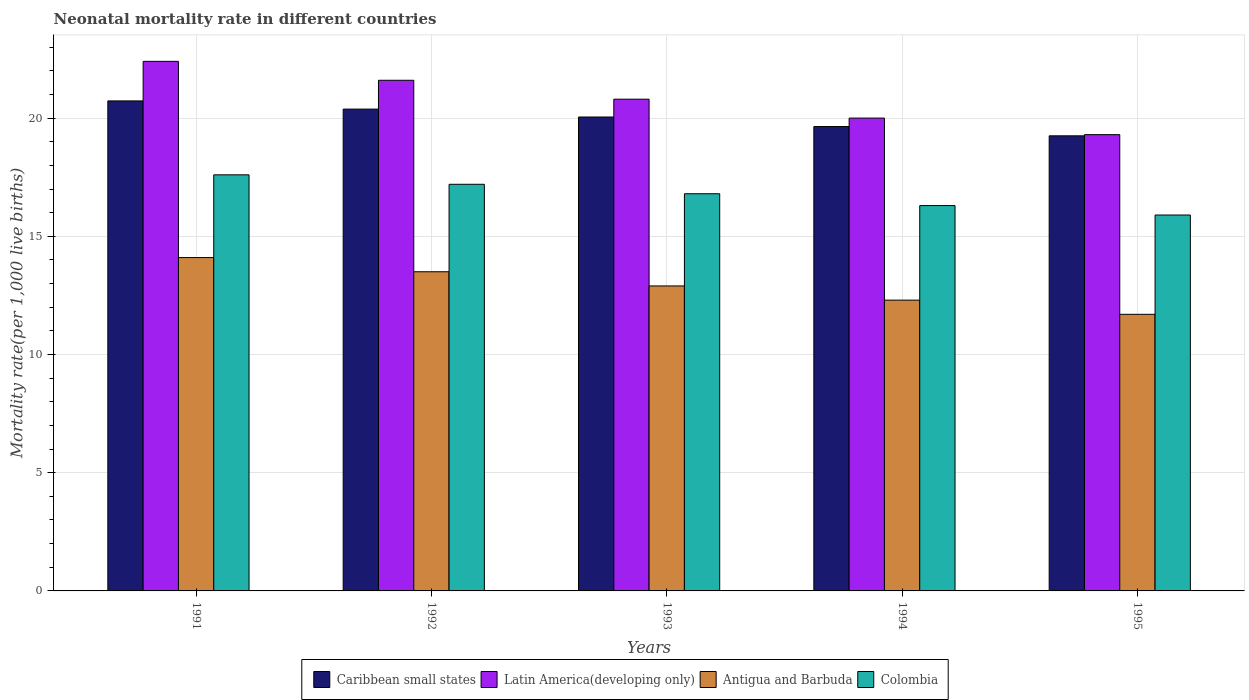How many different coloured bars are there?
Your response must be concise. 4. How many groups of bars are there?
Offer a very short reply. 5. How many bars are there on the 5th tick from the right?
Your answer should be very brief. 4. What is the neonatal mortality rate in Caribbean small states in 1994?
Offer a very short reply. 19.64. Across all years, what is the maximum neonatal mortality rate in Antigua and Barbuda?
Offer a very short reply. 14.1. Across all years, what is the minimum neonatal mortality rate in Antigua and Barbuda?
Offer a terse response. 11.7. In which year was the neonatal mortality rate in Caribbean small states maximum?
Your answer should be very brief. 1991. In which year was the neonatal mortality rate in Latin America(developing only) minimum?
Your answer should be very brief. 1995. What is the total neonatal mortality rate in Caribbean small states in the graph?
Provide a short and direct response. 100.05. What is the difference between the neonatal mortality rate in Antigua and Barbuda in 1993 and that in 1995?
Offer a very short reply. 1.2. What is the difference between the neonatal mortality rate in Caribbean small states in 1994 and the neonatal mortality rate in Latin America(developing only) in 1995?
Offer a terse response. 0.34. What is the average neonatal mortality rate in Caribbean small states per year?
Make the answer very short. 20.01. In the year 1995, what is the difference between the neonatal mortality rate in Latin America(developing only) and neonatal mortality rate in Antigua and Barbuda?
Make the answer very short. 7.6. What is the ratio of the neonatal mortality rate in Antigua and Barbuda in 1991 to that in 1992?
Ensure brevity in your answer.  1.04. What is the difference between the highest and the second highest neonatal mortality rate in Antigua and Barbuda?
Your answer should be compact. 0.6. What is the difference between the highest and the lowest neonatal mortality rate in Antigua and Barbuda?
Your answer should be compact. 2.4. Is the sum of the neonatal mortality rate in Caribbean small states in 1994 and 1995 greater than the maximum neonatal mortality rate in Latin America(developing only) across all years?
Provide a succinct answer. Yes. What does the 3rd bar from the left in 1994 represents?
Ensure brevity in your answer.  Antigua and Barbuda. What does the 3rd bar from the right in 1991 represents?
Ensure brevity in your answer.  Latin America(developing only). Is it the case that in every year, the sum of the neonatal mortality rate in Antigua and Barbuda and neonatal mortality rate in Latin America(developing only) is greater than the neonatal mortality rate in Caribbean small states?
Your answer should be compact. Yes. Are the values on the major ticks of Y-axis written in scientific E-notation?
Offer a very short reply. No. Does the graph contain any zero values?
Offer a very short reply. No. How are the legend labels stacked?
Your answer should be compact. Horizontal. What is the title of the graph?
Your answer should be very brief. Neonatal mortality rate in different countries. Does "Mexico" appear as one of the legend labels in the graph?
Give a very brief answer. No. What is the label or title of the Y-axis?
Your response must be concise. Mortality rate(per 1,0 live births). What is the Mortality rate(per 1,000 live births) of Caribbean small states in 1991?
Your response must be concise. 20.73. What is the Mortality rate(per 1,000 live births) of Latin America(developing only) in 1991?
Give a very brief answer. 22.4. What is the Mortality rate(per 1,000 live births) of Antigua and Barbuda in 1991?
Make the answer very short. 14.1. What is the Mortality rate(per 1,000 live births) of Colombia in 1991?
Provide a short and direct response. 17.6. What is the Mortality rate(per 1,000 live births) in Caribbean small states in 1992?
Provide a succinct answer. 20.38. What is the Mortality rate(per 1,000 live births) in Latin America(developing only) in 1992?
Ensure brevity in your answer.  21.6. What is the Mortality rate(per 1,000 live births) of Antigua and Barbuda in 1992?
Keep it short and to the point. 13.5. What is the Mortality rate(per 1,000 live births) in Caribbean small states in 1993?
Ensure brevity in your answer.  20.05. What is the Mortality rate(per 1,000 live births) of Latin America(developing only) in 1993?
Keep it short and to the point. 20.8. What is the Mortality rate(per 1,000 live births) in Antigua and Barbuda in 1993?
Offer a very short reply. 12.9. What is the Mortality rate(per 1,000 live births) of Colombia in 1993?
Make the answer very short. 16.8. What is the Mortality rate(per 1,000 live births) in Caribbean small states in 1994?
Your answer should be compact. 19.64. What is the Mortality rate(per 1,000 live births) of Antigua and Barbuda in 1994?
Your answer should be very brief. 12.3. What is the Mortality rate(per 1,000 live births) in Caribbean small states in 1995?
Offer a very short reply. 19.25. What is the Mortality rate(per 1,000 live births) of Latin America(developing only) in 1995?
Ensure brevity in your answer.  19.3. What is the Mortality rate(per 1,000 live births) in Colombia in 1995?
Offer a terse response. 15.9. Across all years, what is the maximum Mortality rate(per 1,000 live births) in Caribbean small states?
Ensure brevity in your answer.  20.73. Across all years, what is the maximum Mortality rate(per 1,000 live births) of Latin America(developing only)?
Your answer should be very brief. 22.4. Across all years, what is the minimum Mortality rate(per 1,000 live births) of Caribbean small states?
Your answer should be compact. 19.25. Across all years, what is the minimum Mortality rate(per 1,000 live births) in Latin America(developing only)?
Offer a very short reply. 19.3. Across all years, what is the minimum Mortality rate(per 1,000 live births) of Antigua and Barbuda?
Give a very brief answer. 11.7. What is the total Mortality rate(per 1,000 live births) of Caribbean small states in the graph?
Provide a short and direct response. 100.05. What is the total Mortality rate(per 1,000 live births) of Latin America(developing only) in the graph?
Give a very brief answer. 104.1. What is the total Mortality rate(per 1,000 live births) in Antigua and Barbuda in the graph?
Offer a terse response. 64.5. What is the total Mortality rate(per 1,000 live births) of Colombia in the graph?
Your response must be concise. 83.8. What is the difference between the Mortality rate(per 1,000 live births) in Caribbean small states in 1991 and that in 1992?
Your answer should be compact. 0.35. What is the difference between the Mortality rate(per 1,000 live births) in Antigua and Barbuda in 1991 and that in 1992?
Your response must be concise. 0.6. What is the difference between the Mortality rate(per 1,000 live births) in Caribbean small states in 1991 and that in 1993?
Ensure brevity in your answer.  0.68. What is the difference between the Mortality rate(per 1,000 live births) in Antigua and Barbuda in 1991 and that in 1993?
Provide a short and direct response. 1.2. What is the difference between the Mortality rate(per 1,000 live births) of Colombia in 1991 and that in 1993?
Offer a very short reply. 0.8. What is the difference between the Mortality rate(per 1,000 live births) in Caribbean small states in 1991 and that in 1994?
Your answer should be compact. 1.08. What is the difference between the Mortality rate(per 1,000 live births) in Latin America(developing only) in 1991 and that in 1994?
Ensure brevity in your answer.  2.4. What is the difference between the Mortality rate(per 1,000 live births) in Antigua and Barbuda in 1991 and that in 1994?
Your answer should be compact. 1.8. What is the difference between the Mortality rate(per 1,000 live births) in Colombia in 1991 and that in 1994?
Offer a very short reply. 1.3. What is the difference between the Mortality rate(per 1,000 live births) in Caribbean small states in 1991 and that in 1995?
Give a very brief answer. 1.48. What is the difference between the Mortality rate(per 1,000 live births) of Colombia in 1991 and that in 1995?
Your answer should be very brief. 1.7. What is the difference between the Mortality rate(per 1,000 live births) in Caribbean small states in 1992 and that in 1993?
Your answer should be compact. 0.33. What is the difference between the Mortality rate(per 1,000 live births) of Latin America(developing only) in 1992 and that in 1993?
Ensure brevity in your answer.  0.8. What is the difference between the Mortality rate(per 1,000 live births) in Caribbean small states in 1992 and that in 1994?
Provide a succinct answer. 0.74. What is the difference between the Mortality rate(per 1,000 live births) of Antigua and Barbuda in 1992 and that in 1994?
Your answer should be very brief. 1.2. What is the difference between the Mortality rate(per 1,000 live births) in Colombia in 1992 and that in 1994?
Make the answer very short. 0.9. What is the difference between the Mortality rate(per 1,000 live births) in Caribbean small states in 1992 and that in 1995?
Your answer should be compact. 1.13. What is the difference between the Mortality rate(per 1,000 live births) of Latin America(developing only) in 1992 and that in 1995?
Make the answer very short. 2.3. What is the difference between the Mortality rate(per 1,000 live births) in Caribbean small states in 1993 and that in 1994?
Keep it short and to the point. 0.4. What is the difference between the Mortality rate(per 1,000 live births) of Colombia in 1993 and that in 1994?
Make the answer very short. 0.5. What is the difference between the Mortality rate(per 1,000 live births) in Caribbean small states in 1993 and that in 1995?
Offer a very short reply. 0.8. What is the difference between the Mortality rate(per 1,000 live births) in Caribbean small states in 1994 and that in 1995?
Your answer should be compact. 0.39. What is the difference between the Mortality rate(per 1,000 live births) in Antigua and Barbuda in 1994 and that in 1995?
Give a very brief answer. 0.6. What is the difference between the Mortality rate(per 1,000 live births) of Caribbean small states in 1991 and the Mortality rate(per 1,000 live births) of Latin America(developing only) in 1992?
Provide a succinct answer. -0.87. What is the difference between the Mortality rate(per 1,000 live births) of Caribbean small states in 1991 and the Mortality rate(per 1,000 live births) of Antigua and Barbuda in 1992?
Keep it short and to the point. 7.23. What is the difference between the Mortality rate(per 1,000 live births) of Caribbean small states in 1991 and the Mortality rate(per 1,000 live births) of Colombia in 1992?
Offer a terse response. 3.53. What is the difference between the Mortality rate(per 1,000 live births) in Latin America(developing only) in 1991 and the Mortality rate(per 1,000 live births) in Colombia in 1992?
Provide a succinct answer. 5.2. What is the difference between the Mortality rate(per 1,000 live births) in Caribbean small states in 1991 and the Mortality rate(per 1,000 live births) in Latin America(developing only) in 1993?
Give a very brief answer. -0.07. What is the difference between the Mortality rate(per 1,000 live births) of Caribbean small states in 1991 and the Mortality rate(per 1,000 live births) of Antigua and Barbuda in 1993?
Your response must be concise. 7.83. What is the difference between the Mortality rate(per 1,000 live births) in Caribbean small states in 1991 and the Mortality rate(per 1,000 live births) in Colombia in 1993?
Your answer should be compact. 3.93. What is the difference between the Mortality rate(per 1,000 live births) in Latin America(developing only) in 1991 and the Mortality rate(per 1,000 live births) in Colombia in 1993?
Your answer should be compact. 5.6. What is the difference between the Mortality rate(per 1,000 live births) of Antigua and Barbuda in 1991 and the Mortality rate(per 1,000 live births) of Colombia in 1993?
Your answer should be very brief. -2.7. What is the difference between the Mortality rate(per 1,000 live births) in Caribbean small states in 1991 and the Mortality rate(per 1,000 live births) in Latin America(developing only) in 1994?
Provide a short and direct response. 0.73. What is the difference between the Mortality rate(per 1,000 live births) in Caribbean small states in 1991 and the Mortality rate(per 1,000 live births) in Antigua and Barbuda in 1994?
Make the answer very short. 8.43. What is the difference between the Mortality rate(per 1,000 live births) in Caribbean small states in 1991 and the Mortality rate(per 1,000 live births) in Colombia in 1994?
Your response must be concise. 4.43. What is the difference between the Mortality rate(per 1,000 live births) in Caribbean small states in 1991 and the Mortality rate(per 1,000 live births) in Latin America(developing only) in 1995?
Your answer should be compact. 1.43. What is the difference between the Mortality rate(per 1,000 live births) of Caribbean small states in 1991 and the Mortality rate(per 1,000 live births) of Antigua and Barbuda in 1995?
Offer a very short reply. 9.03. What is the difference between the Mortality rate(per 1,000 live births) in Caribbean small states in 1991 and the Mortality rate(per 1,000 live births) in Colombia in 1995?
Offer a terse response. 4.83. What is the difference between the Mortality rate(per 1,000 live births) in Latin America(developing only) in 1991 and the Mortality rate(per 1,000 live births) in Antigua and Barbuda in 1995?
Give a very brief answer. 10.7. What is the difference between the Mortality rate(per 1,000 live births) in Caribbean small states in 1992 and the Mortality rate(per 1,000 live births) in Latin America(developing only) in 1993?
Offer a terse response. -0.42. What is the difference between the Mortality rate(per 1,000 live births) in Caribbean small states in 1992 and the Mortality rate(per 1,000 live births) in Antigua and Barbuda in 1993?
Your response must be concise. 7.48. What is the difference between the Mortality rate(per 1,000 live births) of Caribbean small states in 1992 and the Mortality rate(per 1,000 live births) of Colombia in 1993?
Give a very brief answer. 3.58. What is the difference between the Mortality rate(per 1,000 live births) of Latin America(developing only) in 1992 and the Mortality rate(per 1,000 live births) of Antigua and Barbuda in 1993?
Your answer should be very brief. 8.7. What is the difference between the Mortality rate(per 1,000 live births) in Latin America(developing only) in 1992 and the Mortality rate(per 1,000 live births) in Colombia in 1993?
Your answer should be compact. 4.8. What is the difference between the Mortality rate(per 1,000 live births) in Antigua and Barbuda in 1992 and the Mortality rate(per 1,000 live births) in Colombia in 1993?
Give a very brief answer. -3.3. What is the difference between the Mortality rate(per 1,000 live births) of Caribbean small states in 1992 and the Mortality rate(per 1,000 live births) of Latin America(developing only) in 1994?
Give a very brief answer. 0.38. What is the difference between the Mortality rate(per 1,000 live births) in Caribbean small states in 1992 and the Mortality rate(per 1,000 live births) in Antigua and Barbuda in 1994?
Offer a terse response. 8.08. What is the difference between the Mortality rate(per 1,000 live births) of Caribbean small states in 1992 and the Mortality rate(per 1,000 live births) of Colombia in 1994?
Keep it short and to the point. 4.08. What is the difference between the Mortality rate(per 1,000 live births) in Antigua and Barbuda in 1992 and the Mortality rate(per 1,000 live births) in Colombia in 1994?
Offer a terse response. -2.8. What is the difference between the Mortality rate(per 1,000 live births) in Caribbean small states in 1992 and the Mortality rate(per 1,000 live births) in Latin America(developing only) in 1995?
Provide a short and direct response. 1.08. What is the difference between the Mortality rate(per 1,000 live births) in Caribbean small states in 1992 and the Mortality rate(per 1,000 live births) in Antigua and Barbuda in 1995?
Ensure brevity in your answer.  8.68. What is the difference between the Mortality rate(per 1,000 live births) in Caribbean small states in 1992 and the Mortality rate(per 1,000 live births) in Colombia in 1995?
Make the answer very short. 4.48. What is the difference between the Mortality rate(per 1,000 live births) of Latin America(developing only) in 1992 and the Mortality rate(per 1,000 live births) of Antigua and Barbuda in 1995?
Offer a terse response. 9.9. What is the difference between the Mortality rate(per 1,000 live births) in Caribbean small states in 1993 and the Mortality rate(per 1,000 live births) in Latin America(developing only) in 1994?
Make the answer very short. 0.05. What is the difference between the Mortality rate(per 1,000 live births) in Caribbean small states in 1993 and the Mortality rate(per 1,000 live births) in Antigua and Barbuda in 1994?
Make the answer very short. 7.75. What is the difference between the Mortality rate(per 1,000 live births) of Caribbean small states in 1993 and the Mortality rate(per 1,000 live births) of Colombia in 1994?
Ensure brevity in your answer.  3.75. What is the difference between the Mortality rate(per 1,000 live births) in Antigua and Barbuda in 1993 and the Mortality rate(per 1,000 live births) in Colombia in 1994?
Your answer should be very brief. -3.4. What is the difference between the Mortality rate(per 1,000 live births) of Caribbean small states in 1993 and the Mortality rate(per 1,000 live births) of Latin America(developing only) in 1995?
Offer a very short reply. 0.75. What is the difference between the Mortality rate(per 1,000 live births) of Caribbean small states in 1993 and the Mortality rate(per 1,000 live births) of Antigua and Barbuda in 1995?
Your response must be concise. 8.35. What is the difference between the Mortality rate(per 1,000 live births) in Caribbean small states in 1993 and the Mortality rate(per 1,000 live births) in Colombia in 1995?
Your response must be concise. 4.15. What is the difference between the Mortality rate(per 1,000 live births) in Latin America(developing only) in 1993 and the Mortality rate(per 1,000 live births) in Antigua and Barbuda in 1995?
Offer a terse response. 9.1. What is the difference between the Mortality rate(per 1,000 live births) of Latin America(developing only) in 1993 and the Mortality rate(per 1,000 live births) of Colombia in 1995?
Your answer should be compact. 4.9. What is the difference between the Mortality rate(per 1,000 live births) of Antigua and Barbuda in 1993 and the Mortality rate(per 1,000 live births) of Colombia in 1995?
Provide a succinct answer. -3. What is the difference between the Mortality rate(per 1,000 live births) of Caribbean small states in 1994 and the Mortality rate(per 1,000 live births) of Latin America(developing only) in 1995?
Your answer should be compact. 0.34. What is the difference between the Mortality rate(per 1,000 live births) of Caribbean small states in 1994 and the Mortality rate(per 1,000 live births) of Antigua and Barbuda in 1995?
Keep it short and to the point. 7.94. What is the difference between the Mortality rate(per 1,000 live births) in Caribbean small states in 1994 and the Mortality rate(per 1,000 live births) in Colombia in 1995?
Your response must be concise. 3.74. What is the difference between the Mortality rate(per 1,000 live births) in Antigua and Barbuda in 1994 and the Mortality rate(per 1,000 live births) in Colombia in 1995?
Give a very brief answer. -3.6. What is the average Mortality rate(per 1,000 live births) in Caribbean small states per year?
Keep it short and to the point. 20.01. What is the average Mortality rate(per 1,000 live births) in Latin America(developing only) per year?
Your answer should be very brief. 20.82. What is the average Mortality rate(per 1,000 live births) of Colombia per year?
Your response must be concise. 16.76. In the year 1991, what is the difference between the Mortality rate(per 1,000 live births) of Caribbean small states and Mortality rate(per 1,000 live births) of Latin America(developing only)?
Your answer should be very brief. -1.67. In the year 1991, what is the difference between the Mortality rate(per 1,000 live births) in Caribbean small states and Mortality rate(per 1,000 live births) in Antigua and Barbuda?
Your answer should be compact. 6.63. In the year 1991, what is the difference between the Mortality rate(per 1,000 live births) of Caribbean small states and Mortality rate(per 1,000 live births) of Colombia?
Your answer should be compact. 3.13. In the year 1992, what is the difference between the Mortality rate(per 1,000 live births) in Caribbean small states and Mortality rate(per 1,000 live births) in Latin America(developing only)?
Provide a succinct answer. -1.22. In the year 1992, what is the difference between the Mortality rate(per 1,000 live births) in Caribbean small states and Mortality rate(per 1,000 live births) in Antigua and Barbuda?
Your answer should be compact. 6.88. In the year 1992, what is the difference between the Mortality rate(per 1,000 live births) of Caribbean small states and Mortality rate(per 1,000 live births) of Colombia?
Ensure brevity in your answer.  3.18. In the year 1992, what is the difference between the Mortality rate(per 1,000 live births) in Latin America(developing only) and Mortality rate(per 1,000 live births) in Antigua and Barbuda?
Offer a very short reply. 8.1. In the year 1992, what is the difference between the Mortality rate(per 1,000 live births) of Antigua and Barbuda and Mortality rate(per 1,000 live births) of Colombia?
Offer a terse response. -3.7. In the year 1993, what is the difference between the Mortality rate(per 1,000 live births) in Caribbean small states and Mortality rate(per 1,000 live births) in Latin America(developing only)?
Make the answer very short. -0.75. In the year 1993, what is the difference between the Mortality rate(per 1,000 live births) in Caribbean small states and Mortality rate(per 1,000 live births) in Antigua and Barbuda?
Your answer should be very brief. 7.15. In the year 1993, what is the difference between the Mortality rate(per 1,000 live births) of Caribbean small states and Mortality rate(per 1,000 live births) of Colombia?
Your answer should be compact. 3.25. In the year 1993, what is the difference between the Mortality rate(per 1,000 live births) in Latin America(developing only) and Mortality rate(per 1,000 live births) in Antigua and Barbuda?
Give a very brief answer. 7.9. In the year 1994, what is the difference between the Mortality rate(per 1,000 live births) of Caribbean small states and Mortality rate(per 1,000 live births) of Latin America(developing only)?
Provide a succinct answer. -0.36. In the year 1994, what is the difference between the Mortality rate(per 1,000 live births) in Caribbean small states and Mortality rate(per 1,000 live births) in Antigua and Barbuda?
Your response must be concise. 7.34. In the year 1994, what is the difference between the Mortality rate(per 1,000 live births) of Caribbean small states and Mortality rate(per 1,000 live births) of Colombia?
Provide a succinct answer. 3.34. In the year 1994, what is the difference between the Mortality rate(per 1,000 live births) of Latin America(developing only) and Mortality rate(per 1,000 live births) of Antigua and Barbuda?
Give a very brief answer. 7.7. In the year 1994, what is the difference between the Mortality rate(per 1,000 live births) in Antigua and Barbuda and Mortality rate(per 1,000 live births) in Colombia?
Provide a short and direct response. -4. In the year 1995, what is the difference between the Mortality rate(per 1,000 live births) in Caribbean small states and Mortality rate(per 1,000 live births) in Latin America(developing only)?
Keep it short and to the point. -0.05. In the year 1995, what is the difference between the Mortality rate(per 1,000 live births) in Caribbean small states and Mortality rate(per 1,000 live births) in Antigua and Barbuda?
Provide a short and direct response. 7.55. In the year 1995, what is the difference between the Mortality rate(per 1,000 live births) in Caribbean small states and Mortality rate(per 1,000 live births) in Colombia?
Provide a short and direct response. 3.35. In the year 1995, what is the difference between the Mortality rate(per 1,000 live births) of Latin America(developing only) and Mortality rate(per 1,000 live births) of Colombia?
Your answer should be very brief. 3.4. In the year 1995, what is the difference between the Mortality rate(per 1,000 live births) of Antigua and Barbuda and Mortality rate(per 1,000 live births) of Colombia?
Offer a terse response. -4.2. What is the ratio of the Mortality rate(per 1,000 live births) of Antigua and Barbuda in 1991 to that in 1992?
Provide a succinct answer. 1.04. What is the ratio of the Mortality rate(per 1,000 live births) of Colombia in 1991 to that in 1992?
Provide a short and direct response. 1.02. What is the ratio of the Mortality rate(per 1,000 live births) of Caribbean small states in 1991 to that in 1993?
Provide a succinct answer. 1.03. What is the ratio of the Mortality rate(per 1,000 live births) of Latin America(developing only) in 1991 to that in 1993?
Make the answer very short. 1.08. What is the ratio of the Mortality rate(per 1,000 live births) in Antigua and Barbuda in 1991 to that in 1993?
Your answer should be compact. 1.09. What is the ratio of the Mortality rate(per 1,000 live births) in Colombia in 1991 to that in 1993?
Ensure brevity in your answer.  1.05. What is the ratio of the Mortality rate(per 1,000 live births) in Caribbean small states in 1991 to that in 1994?
Your answer should be very brief. 1.06. What is the ratio of the Mortality rate(per 1,000 live births) in Latin America(developing only) in 1991 to that in 1994?
Your answer should be very brief. 1.12. What is the ratio of the Mortality rate(per 1,000 live births) of Antigua and Barbuda in 1991 to that in 1994?
Offer a terse response. 1.15. What is the ratio of the Mortality rate(per 1,000 live births) in Colombia in 1991 to that in 1994?
Ensure brevity in your answer.  1.08. What is the ratio of the Mortality rate(per 1,000 live births) in Caribbean small states in 1991 to that in 1995?
Keep it short and to the point. 1.08. What is the ratio of the Mortality rate(per 1,000 live births) of Latin America(developing only) in 1991 to that in 1995?
Your answer should be compact. 1.16. What is the ratio of the Mortality rate(per 1,000 live births) of Antigua and Barbuda in 1991 to that in 1995?
Provide a succinct answer. 1.21. What is the ratio of the Mortality rate(per 1,000 live births) of Colombia in 1991 to that in 1995?
Offer a very short reply. 1.11. What is the ratio of the Mortality rate(per 1,000 live births) of Caribbean small states in 1992 to that in 1993?
Ensure brevity in your answer.  1.02. What is the ratio of the Mortality rate(per 1,000 live births) of Latin America(developing only) in 1992 to that in 1993?
Give a very brief answer. 1.04. What is the ratio of the Mortality rate(per 1,000 live births) in Antigua and Barbuda in 1992 to that in 1993?
Provide a short and direct response. 1.05. What is the ratio of the Mortality rate(per 1,000 live births) in Colombia in 1992 to that in 1993?
Provide a succinct answer. 1.02. What is the ratio of the Mortality rate(per 1,000 live births) of Caribbean small states in 1992 to that in 1994?
Provide a short and direct response. 1.04. What is the ratio of the Mortality rate(per 1,000 live births) in Antigua and Barbuda in 1992 to that in 1994?
Offer a very short reply. 1.1. What is the ratio of the Mortality rate(per 1,000 live births) of Colombia in 1992 to that in 1994?
Give a very brief answer. 1.06. What is the ratio of the Mortality rate(per 1,000 live births) in Caribbean small states in 1992 to that in 1995?
Your answer should be compact. 1.06. What is the ratio of the Mortality rate(per 1,000 live births) of Latin America(developing only) in 1992 to that in 1995?
Make the answer very short. 1.12. What is the ratio of the Mortality rate(per 1,000 live births) of Antigua and Barbuda in 1992 to that in 1995?
Your response must be concise. 1.15. What is the ratio of the Mortality rate(per 1,000 live births) of Colombia in 1992 to that in 1995?
Give a very brief answer. 1.08. What is the ratio of the Mortality rate(per 1,000 live births) of Caribbean small states in 1993 to that in 1994?
Offer a very short reply. 1.02. What is the ratio of the Mortality rate(per 1,000 live births) of Antigua and Barbuda in 1993 to that in 1994?
Your answer should be compact. 1.05. What is the ratio of the Mortality rate(per 1,000 live births) in Colombia in 1993 to that in 1994?
Give a very brief answer. 1.03. What is the ratio of the Mortality rate(per 1,000 live births) of Caribbean small states in 1993 to that in 1995?
Offer a terse response. 1.04. What is the ratio of the Mortality rate(per 1,000 live births) in Latin America(developing only) in 1993 to that in 1995?
Offer a very short reply. 1.08. What is the ratio of the Mortality rate(per 1,000 live births) of Antigua and Barbuda in 1993 to that in 1995?
Offer a very short reply. 1.1. What is the ratio of the Mortality rate(per 1,000 live births) in Colombia in 1993 to that in 1995?
Keep it short and to the point. 1.06. What is the ratio of the Mortality rate(per 1,000 live births) in Caribbean small states in 1994 to that in 1995?
Your response must be concise. 1.02. What is the ratio of the Mortality rate(per 1,000 live births) in Latin America(developing only) in 1994 to that in 1995?
Your answer should be compact. 1.04. What is the ratio of the Mortality rate(per 1,000 live births) of Antigua and Barbuda in 1994 to that in 1995?
Your answer should be very brief. 1.05. What is the ratio of the Mortality rate(per 1,000 live births) of Colombia in 1994 to that in 1995?
Provide a short and direct response. 1.03. What is the difference between the highest and the second highest Mortality rate(per 1,000 live births) of Caribbean small states?
Make the answer very short. 0.35. What is the difference between the highest and the second highest Mortality rate(per 1,000 live births) in Antigua and Barbuda?
Provide a succinct answer. 0.6. What is the difference between the highest and the second highest Mortality rate(per 1,000 live births) in Colombia?
Offer a terse response. 0.4. What is the difference between the highest and the lowest Mortality rate(per 1,000 live births) in Caribbean small states?
Give a very brief answer. 1.48. 